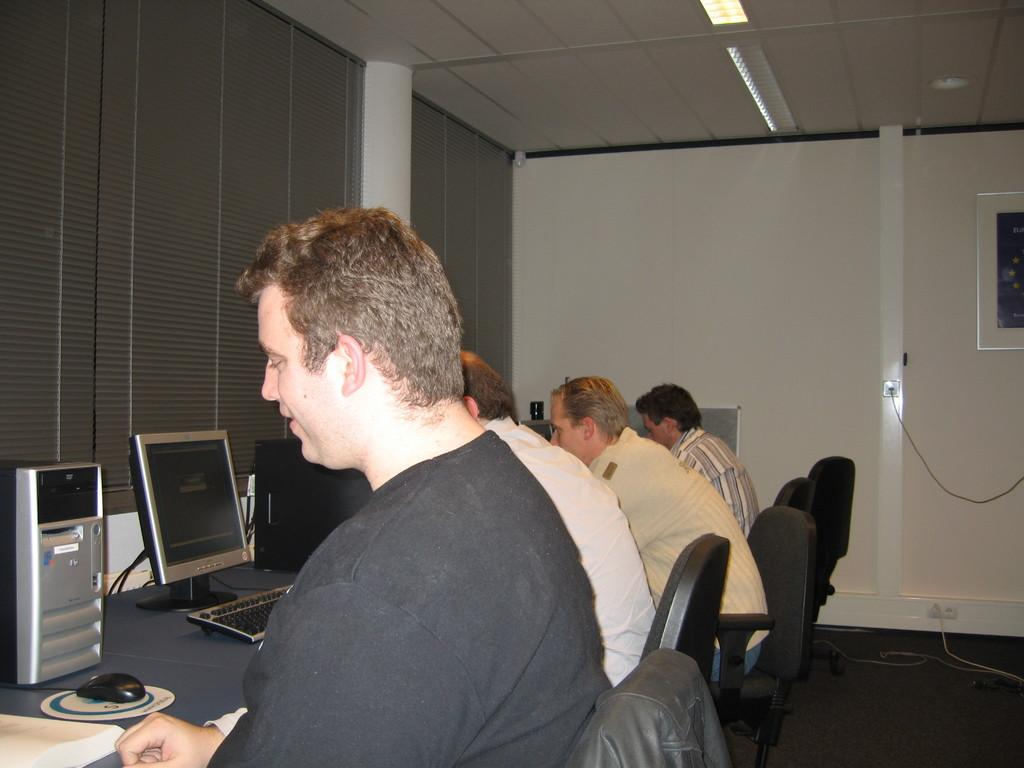What are the people in the image doing? There is a group of people sitting on chairs in the image. What is in front of the chairs? There is a table in front of the chairs. What electronic devices can be seen on the table? Computers, CPUs, and mouse devices are on the table. What is visible behind the people and table? There is a wall visible in the image. Can you see any examples of stars on the ground in the image? There are no stars visible in the image, and the ground is not shown. 